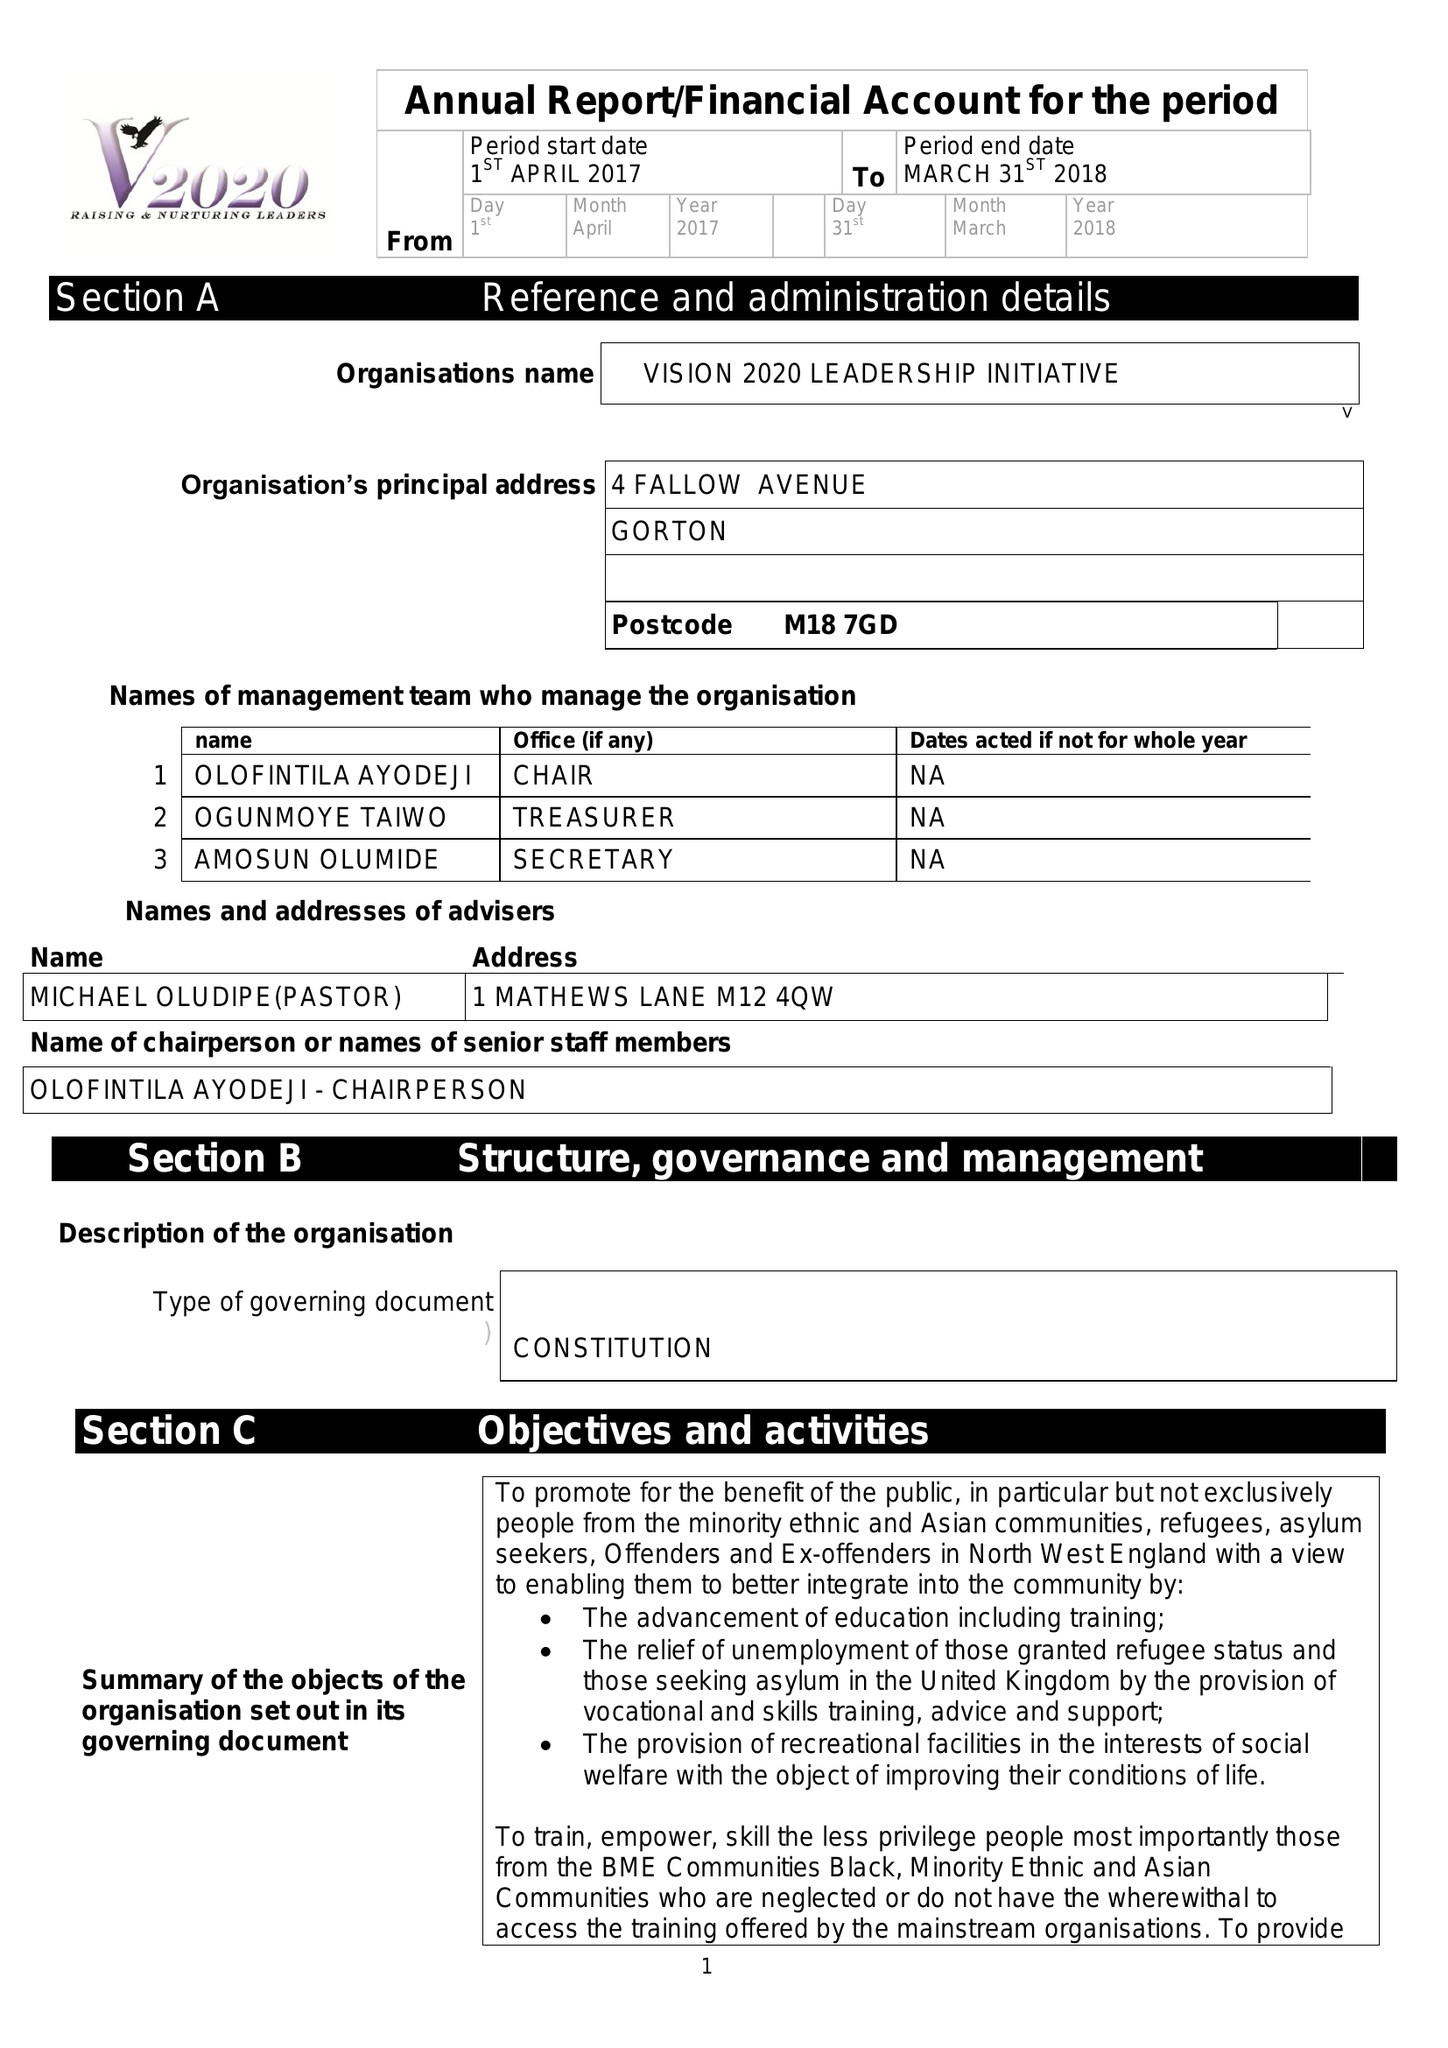What is the value for the address__postcode?
Answer the question using a single word or phrase. M18 7GD 